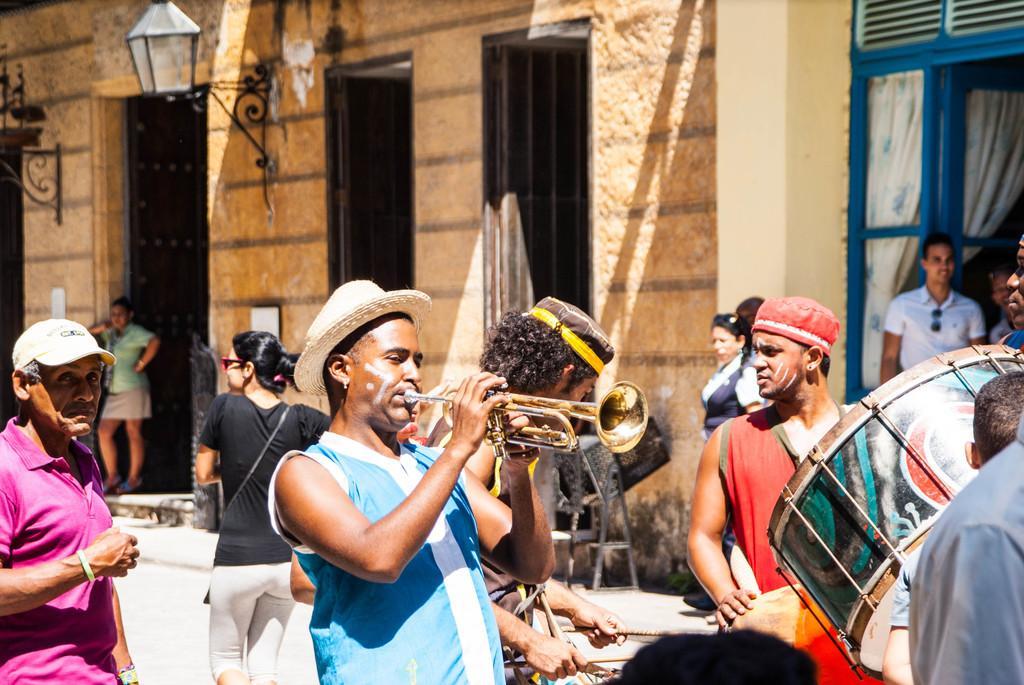Can you describe this image briefly? There are a four people who are playing a musical band on a road. As one is playing a saxophone and one is playing a drum with drumsticks. In the background we can see a woman walking and another who is standing on the top left. There is a two who are standing on the top right. 